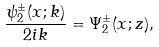Convert formula to latex. <formula><loc_0><loc_0><loc_500><loc_500>\frac { \psi ^ { \pm } _ { 2 } ( x ; k ) } { 2 i k } = \Psi ^ { \pm } _ { 2 } ( x ; z ) ,</formula> 